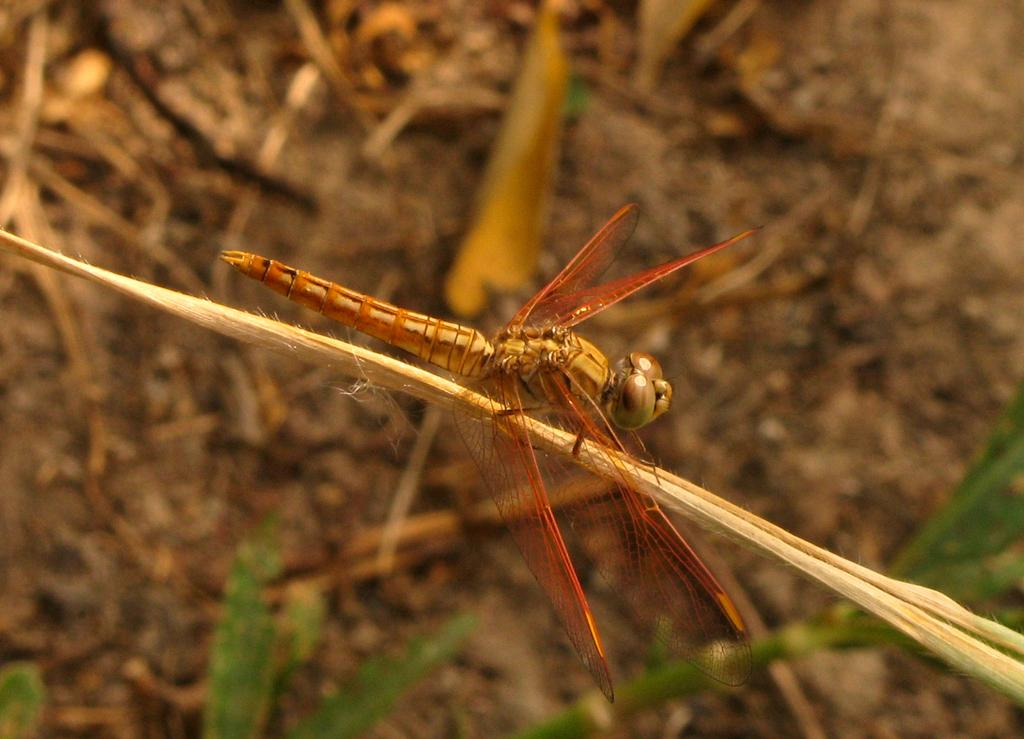What type of creature is present in the image? There is an insect in the image. What are the main features of the insect? The insect has wings and legs. What is the insect standing on in the image? The insect is standing on a dry leaf of a plant. Can you describe the background of the image? The background of the image is blurred. What type of potato is visible in the image? There is no potato present in the image. Is the insect sitting on a sofa in the image? There is no sofa present in the image; the insect is standing on a dry leaf of a plant. 